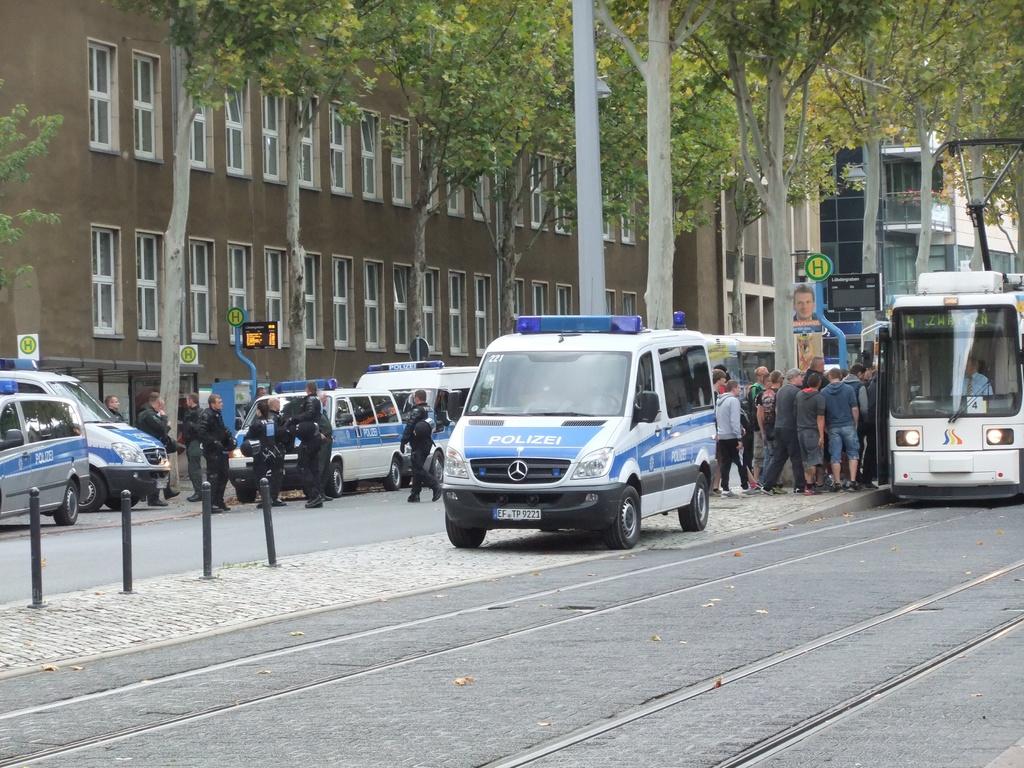What kind of vehicles are those?
Provide a succinct answer. Police. 